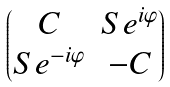<formula> <loc_0><loc_0><loc_500><loc_500>\begin{pmatrix} C & S e ^ { i \varphi } \\ S e ^ { - i \varphi } & - C \end{pmatrix}</formula> 